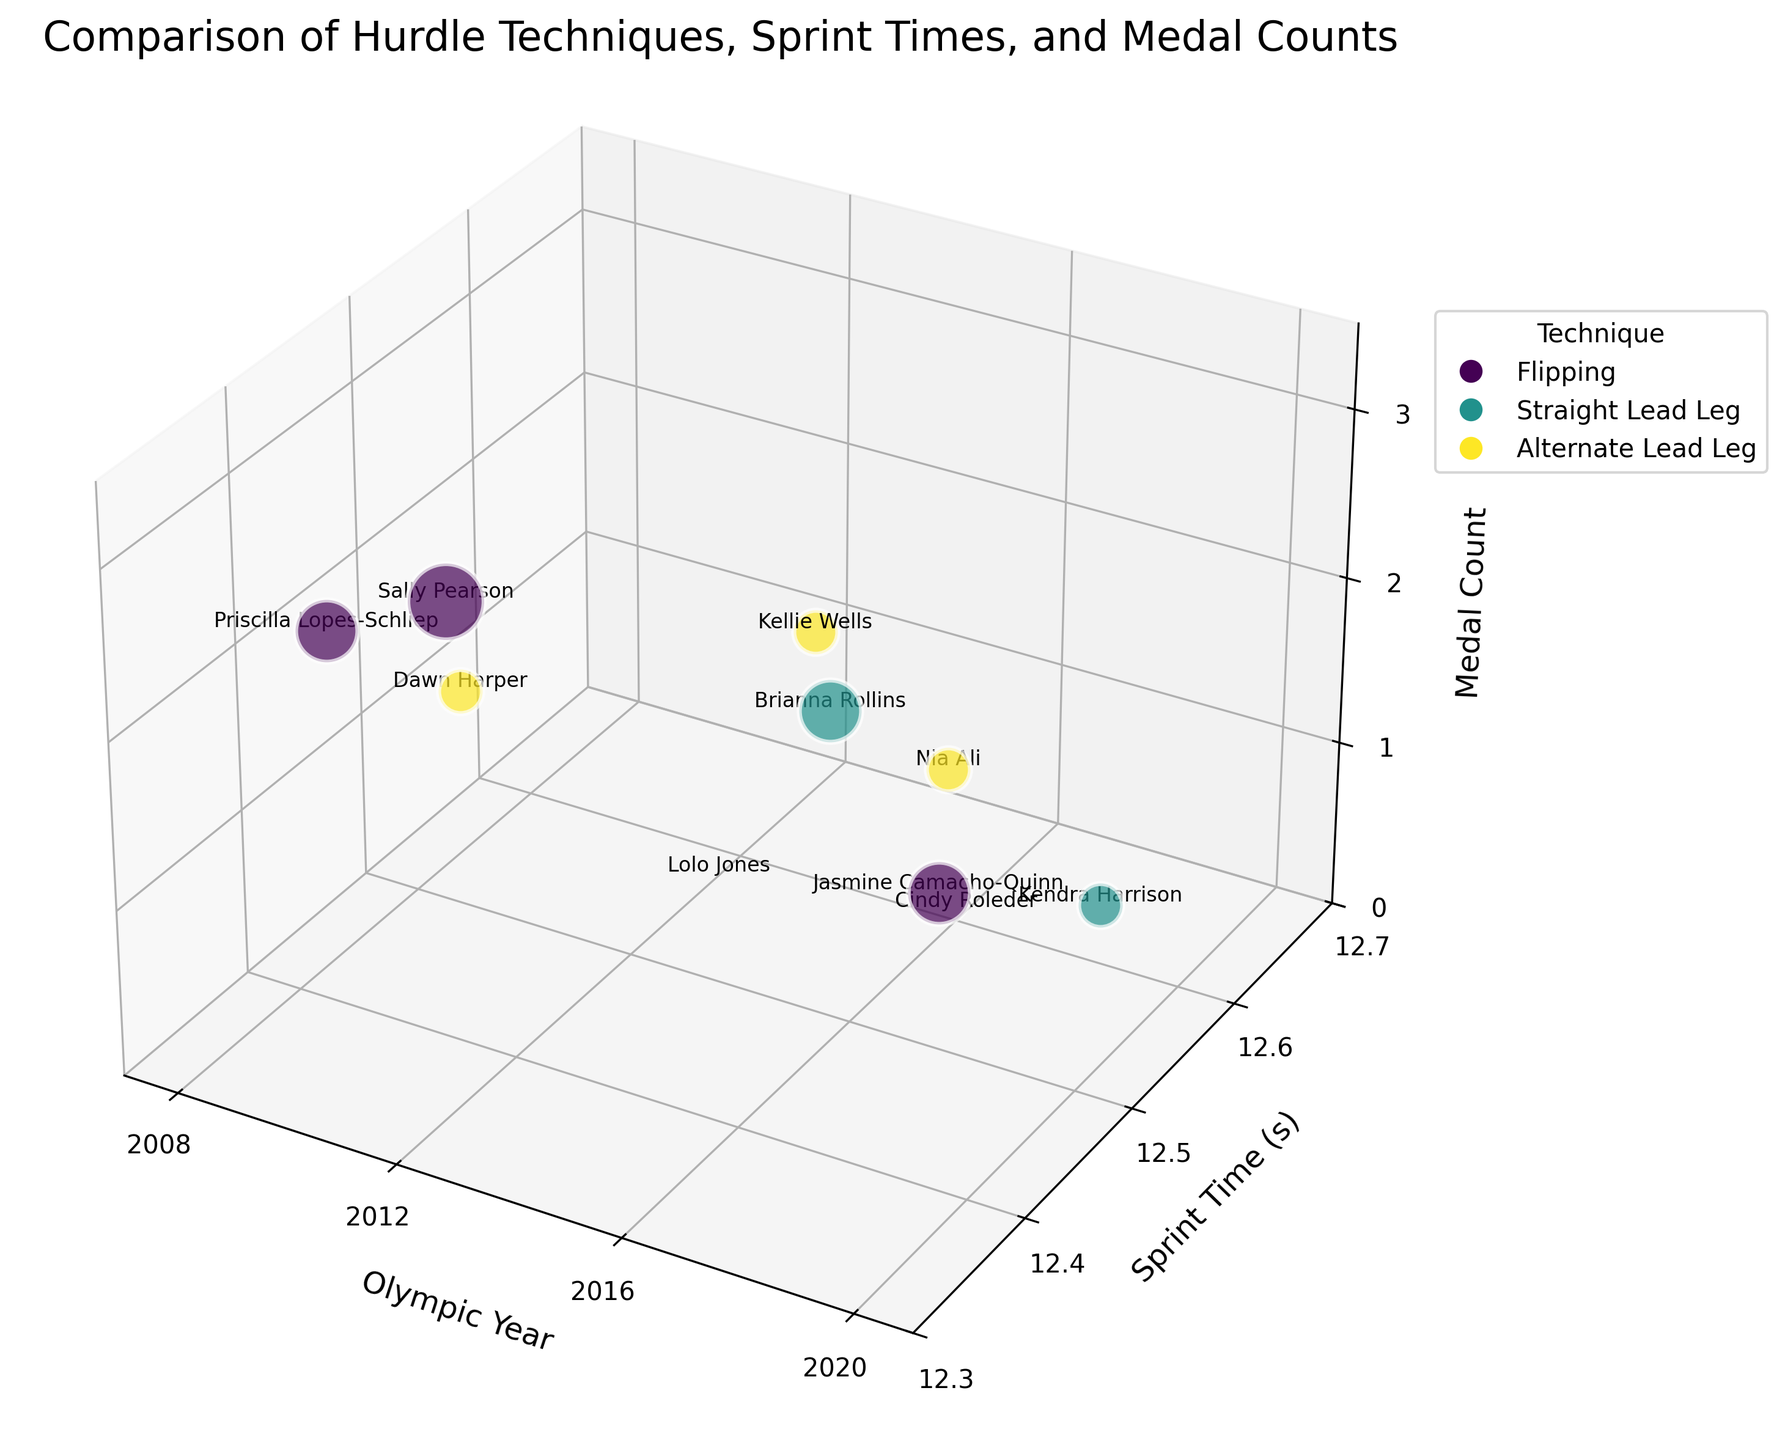what is the highest medal count shown in the figure? The z-axis represents the medal count. The highest value shown is 3 medals.
Answer: 3 Which athlete has the fastest sprint time in the 2012 Olympics? Look for the data points where the Olympic year is 2012 and find the one with the lowest sprint time on the y-axis. Sally Pearson has a sprint time of 12.35 seconds.
Answer: Sally Pearson Which technique is used most frequently across the years represented in this figure? Count the occurrences of each technique color-coded on the plot. The “Flipping” technique appears most frequently.
Answer: Flipping What was the total medal count achieved in the 2016 Olympics according to this figure? Focus on the data points for the year 2016, then sum the medal counts. Brianna Rollins (2), Nia Ali (1), and Cindy Roleder (0): 2+1+0=3
Answer: 3 Who has the slowest sprint time in the figure and what is that time? Check the highest sprint time on the y-axis. Cindy Roleder has the slowest time of 12.61 seconds.
Answer: Cindy Roleder, 12.61 seconds Which Olympic year had the most athletes represented in this figure? Compare the number of data points for each Olympic year: 2008, 2012, 2016, and 2020. The year 2016 has the most athletes represented with 3 athletes.
Answer: 2016 How many medals did athletes using the "Straight Lead Leg" technique win in total? Identify the bubbles colored for the “Straight Lead Leg” technique and sum the medal counts. With 2 medals (Brianna Rollins) + 0 medals (Lolo Jones) + 1 medal (Kendra Harrison) = 3
Answer: 3 What is the average sprint time of athletes using the "Flipping" technique? Add the sprint times of all athletes using the “Flipping” technique and divide by the number of instances: (12.35 + 12.37 + 12.43 + 12.61) / 4 = 12.44
Answer: 12.44 Which technique had the highest medal count for a single athlete and what was the athlete’s name? Find all techniques' maximum single athlete's medal count. Sally Pearson used the “Flipping” technique to win 3 medals.
Answer: Flipping, Sally Pearson 